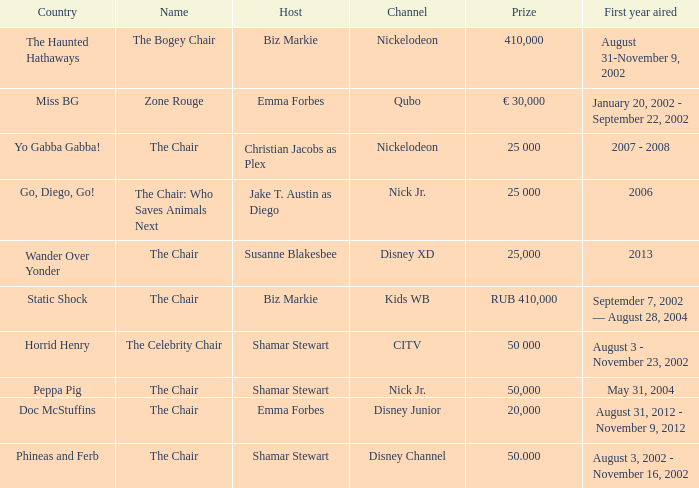What was the first year that had a prize of 50,000? May 31, 2004. 